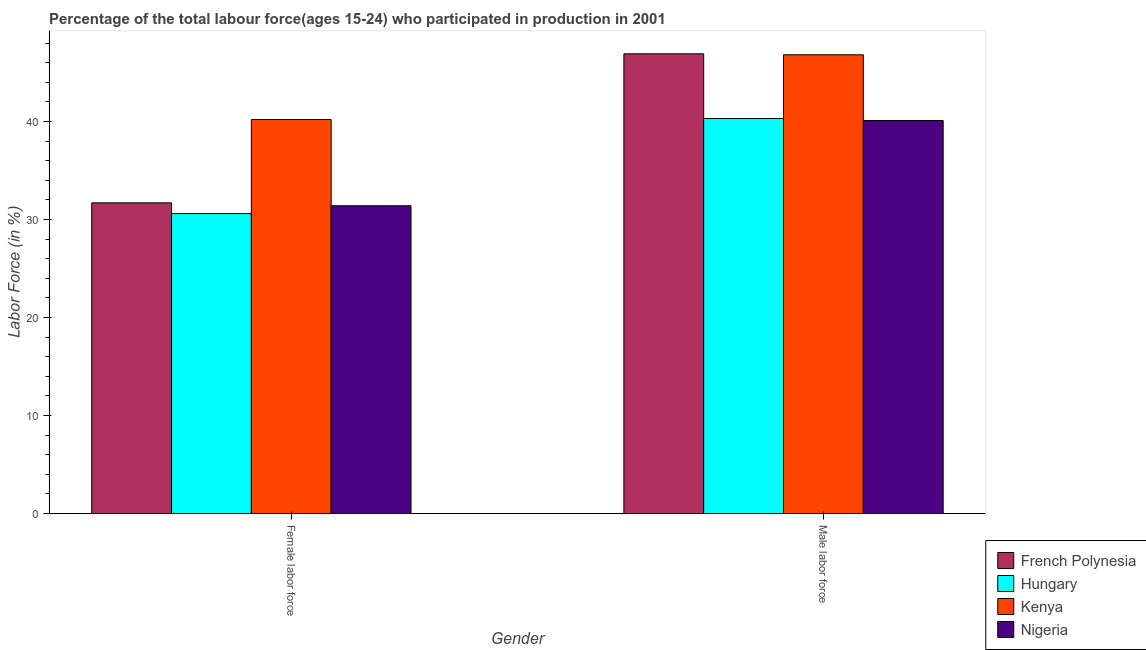How many different coloured bars are there?
Your answer should be very brief. 4. Are the number of bars per tick equal to the number of legend labels?
Ensure brevity in your answer.  Yes. What is the label of the 1st group of bars from the left?
Your answer should be compact. Female labor force. What is the percentage of male labour force in French Polynesia?
Ensure brevity in your answer.  46.9. Across all countries, what is the maximum percentage of female labor force?
Provide a succinct answer. 40.2. Across all countries, what is the minimum percentage of female labor force?
Your answer should be very brief. 30.6. In which country was the percentage of female labor force maximum?
Ensure brevity in your answer.  Kenya. In which country was the percentage of female labor force minimum?
Keep it short and to the point. Hungary. What is the total percentage of female labor force in the graph?
Provide a succinct answer. 133.9. What is the difference between the percentage of male labour force in Hungary and that in Kenya?
Provide a succinct answer. -6.5. What is the difference between the percentage of male labour force in Hungary and the percentage of female labor force in Kenya?
Your answer should be very brief. 0.1. What is the average percentage of female labor force per country?
Offer a terse response. 33.48. What is the difference between the percentage of male labour force and percentage of female labor force in Kenya?
Give a very brief answer. 6.6. In how many countries, is the percentage of female labor force greater than 4 %?
Offer a very short reply. 4. What is the ratio of the percentage of female labor force in Nigeria to that in Kenya?
Make the answer very short. 0.78. Is the percentage of male labour force in Nigeria less than that in French Polynesia?
Keep it short and to the point. Yes. What does the 1st bar from the left in Female labor force represents?
Keep it short and to the point. French Polynesia. What does the 3rd bar from the right in Female labor force represents?
Provide a short and direct response. Hungary. How many bars are there?
Give a very brief answer. 8. What is the difference between two consecutive major ticks on the Y-axis?
Keep it short and to the point. 10. Does the graph contain grids?
Give a very brief answer. No. Where does the legend appear in the graph?
Give a very brief answer. Bottom right. How many legend labels are there?
Ensure brevity in your answer.  4. How are the legend labels stacked?
Your response must be concise. Vertical. What is the title of the graph?
Provide a succinct answer. Percentage of the total labour force(ages 15-24) who participated in production in 2001. Does "Pacific island small states" appear as one of the legend labels in the graph?
Ensure brevity in your answer.  No. What is the label or title of the X-axis?
Your answer should be compact. Gender. What is the label or title of the Y-axis?
Offer a very short reply. Labor Force (in %). What is the Labor Force (in %) in French Polynesia in Female labor force?
Keep it short and to the point. 31.7. What is the Labor Force (in %) in Hungary in Female labor force?
Your answer should be very brief. 30.6. What is the Labor Force (in %) of Kenya in Female labor force?
Your answer should be very brief. 40.2. What is the Labor Force (in %) of Nigeria in Female labor force?
Your response must be concise. 31.4. What is the Labor Force (in %) of French Polynesia in Male labor force?
Your answer should be very brief. 46.9. What is the Labor Force (in %) in Hungary in Male labor force?
Give a very brief answer. 40.3. What is the Labor Force (in %) of Kenya in Male labor force?
Offer a terse response. 46.8. What is the Labor Force (in %) of Nigeria in Male labor force?
Offer a terse response. 40.1. Across all Gender, what is the maximum Labor Force (in %) in French Polynesia?
Provide a succinct answer. 46.9. Across all Gender, what is the maximum Labor Force (in %) of Hungary?
Provide a succinct answer. 40.3. Across all Gender, what is the maximum Labor Force (in %) of Kenya?
Give a very brief answer. 46.8. Across all Gender, what is the maximum Labor Force (in %) in Nigeria?
Your answer should be very brief. 40.1. Across all Gender, what is the minimum Labor Force (in %) of French Polynesia?
Give a very brief answer. 31.7. Across all Gender, what is the minimum Labor Force (in %) of Hungary?
Your answer should be very brief. 30.6. Across all Gender, what is the minimum Labor Force (in %) in Kenya?
Offer a terse response. 40.2. Across all Gender, what is the minimum Labor Force (in %) in Nigeria?
Offer a terse response. 31.4. What is the total Labor Force (in %) of French Polynesia in the graph?
Provide a short and direct response. 78.6. What is the total Labor Force (in %) of Hungary in the graph?
Offer a very short reply. 70.9. What is the total Labor Force (in %) in Nigeria in the graph?
Give a very brief answer. 71.5. What is the difference between the Labor Force (in %) in French Polynesia in Female labor force and that in Male labor force?
Your response must be concise. -15.2. What is the difference between the Labor Force (in %) in French Polynesia in Female labor force and the Labor Force (in %) in Kenya in Male labor force?
Your response must be concise. -15.1. What is the difference between the Labor Force (in %) of French Polynesia in Female labor force and the Labor Force (in %) of Nigeria in Male labor force?
Provide a succinct answer. -8.4. What is the difference between the Labor Force (in %) of Hungary in Female labor force and the Labor Force (in %) of Kenya in Male labor force?
Give a very brief answer. -16.2. What is the difference between the Labor Force (in %) in Hungary in Female labor force and the Labor Force (in %) in Nigeria in Male labor force?
Make the answer very short. -9.5. What is the difference between the Labor Force (in %) of Kenya in Female labor force and the Labor Force (in %) of Nigeria in Male labor force?
Provide a succinct answer. 0.1. What is the average Labor Force (in %) of French Polynesia per Gender?
Keep it short and to the point. 39.3. What is the average Labor Force (in %) of Hungary per Gender?
Your answer should be very brief. 35.45. What is the average Labor Force (in %) of Kenya per Gender?
Provide a succinct answer. 43.5. What is the average Labor Force (in %) of Nigeria per Gender?
Offer a very short reply. 35.75. What is the difference between the Labor Force (in %) of French Polynesia and Labor Force (in %) of Hungary in Female labor force?
Make the answer very short. 1.1. What is the difference between the Labor Force (in %) in French Polynesia and Labor Force (in %) in Nigeria in Female labor force?
Your answer should be very brief. 0.3. What is the difference between the Labor Force (in %) of Hungary and Labor Force (in %) of Nigeria in Female labor force?
Offer a terse response. -0.8. What is the difference between the Labor Force (in %) of Kenya and Labor Force (in %) of Nigeria in Female labor force?
Keep it short and to the point. 8.8. What is the difference between the Labor Force (in %) of French Polynesia and Labor Force (in %) of Hungary in Male labor force?
Make the answer very short. 6.6. What is the difference between the Labor Force (in %) of French Polynesia and Labor Force (in %) of Nigeria in Male labor force?
Offer a very short reply. 6.8. What is the difference between the Labor Force (in %) of Hungary and Labor Force (in %) of Kenya in Male labor force?
Your response must be concise. -6.5. What is the difference between the Labor Force (in %) in Kenya and Labor Force (in %) in Nigeria in Male labor force?
Offer a very short reply. 6.7. What is the ratio of the Labor Force (in %) of French Polynesia in Female labor force to that in Male labor force?
Ensure brevity in your answer.  0.68. What is the ratio of the Labor Force (in %) of Hungary in Female labor force to that in Male labor force?
Provide a short and direct response. 0.76. What is the ratio of the Labor Force (in %) in Kenya in Female labor force to that in Male labor force?
Your response must be concise. 0.86. What is the ratio of the Labor Force (in %) in Nigeria in Female labor force to that in Male labor force?
Give a very brief answer. 0.78. What is the difference between the highest and the second highest Labor Force (in %) of French Polynesia?
Ensure brevity in your answer.  15.2. What is the difference between the highest and the second highest Labor Force (in %) in Nigeria?
Give a very brief answer. 8.7. What is the difference between the highest and the lowest Labor Force (in %) in French Polynesia?
Provide a short and direct response. 15.2. What is the difference between the highest and the lowest Labor Force (in %) of Kenya?
Keep it short and to the point. 6.6. 